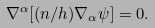<formula> <loc_0><loc_0><loc_500><loc_500>\nabla ^ { \alpha } [ ( n / h ) \nabla _ { \alpha } \psi ] = 0 .</formula> 